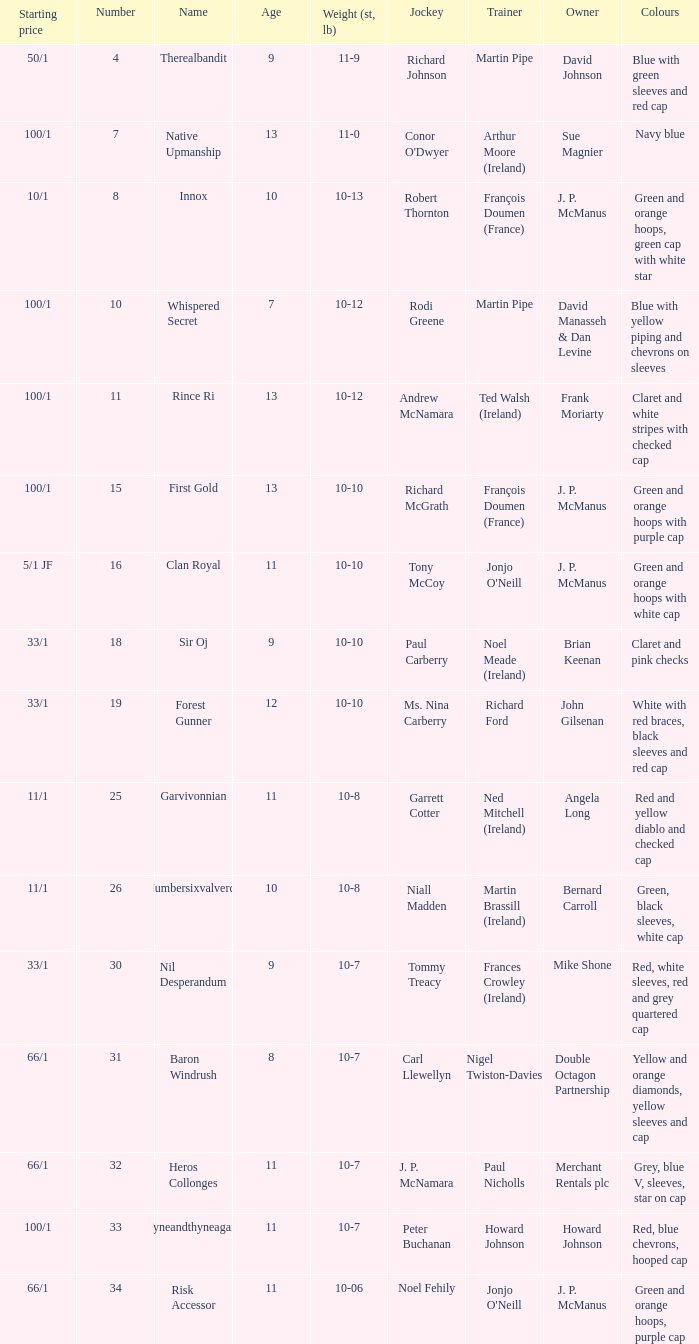What was the name of the contestant with an owner named david johnson? Therealbandit. 